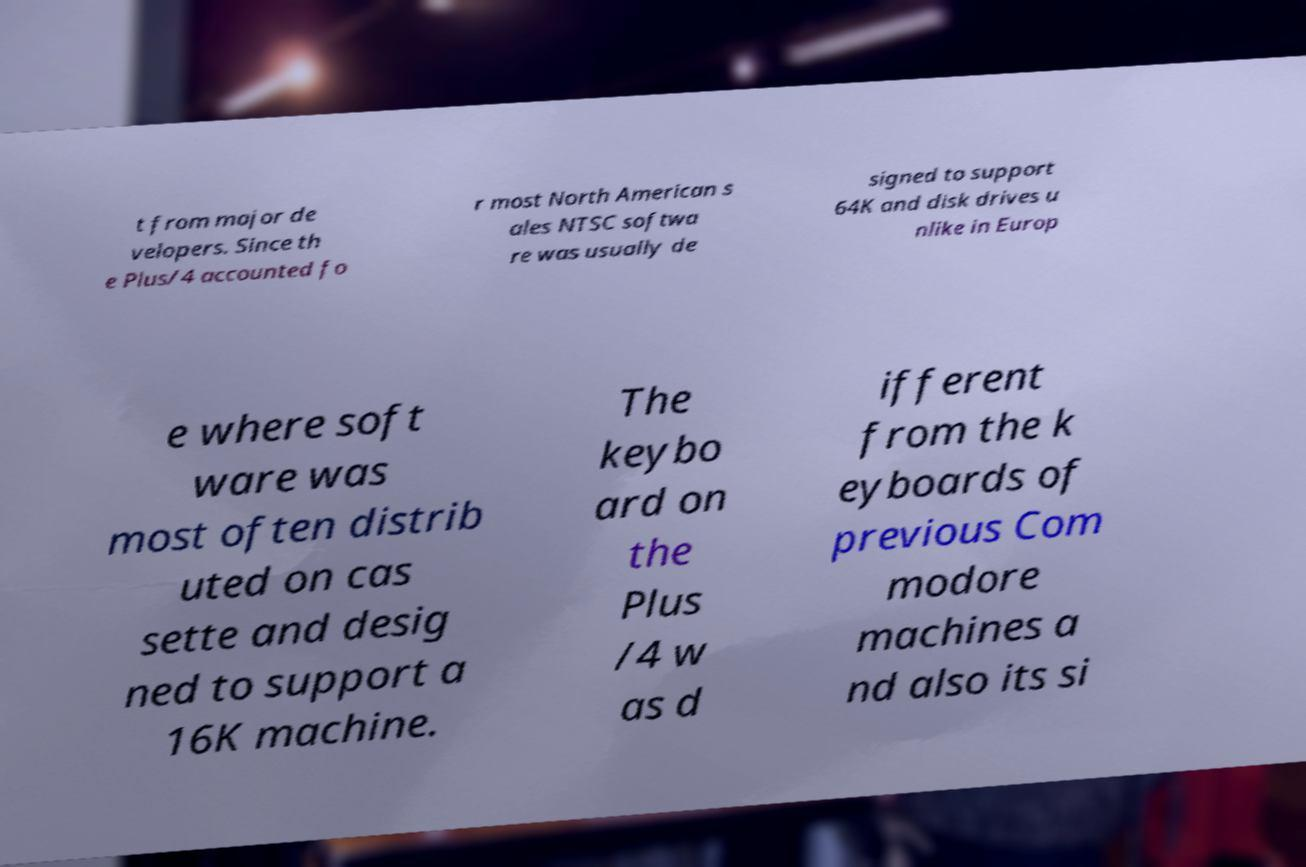Please read and relay the text visible in this image. What does it say? t from major de velopers. Since th e Plus/4 accounted fo r most North American s ales NTSC softwa re was usually de signed to support 64K and disk drives u nlike in Europ e where soft ware was most often distrib uted on cas sette and desig ned to support a 16K machine. The keybo ard on the Plus /4 w as d ifferent from the k eyboards of previous Com modore machines a nd also its si 